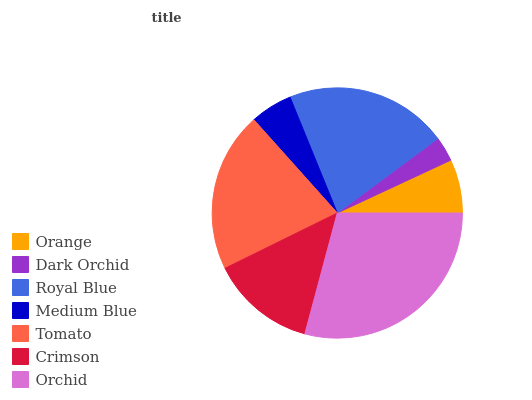Is Dark Orchid the minimum?
Answer yes or no. Yes. Is Orchid the maximum?
Answer yes or no. Yes. Is Royal Blue the minimum?
Answer yes or no. No. Is Royal Blue the maximum?
Answer yes or no. No. Is Royal Blue greater than Dark Orchid?
Answer yes or no. Yes. Is Dark Orchid less than Royal Blue?
Answer yes or no. Yes. Is Dark Orchid greater than Royal Blue?
Answer yes or no. No. Is Royal Blue less than Dark Orchid?
Answer yes or no. No. Is Crimson the high median?
Answer yes or no. Yes. Is Crimson the low median?
Answer yes or no. Yes. Is Orchid the high median?
Answer yes or no. No. Is Orange the low median?
Answer yes or no. No. 